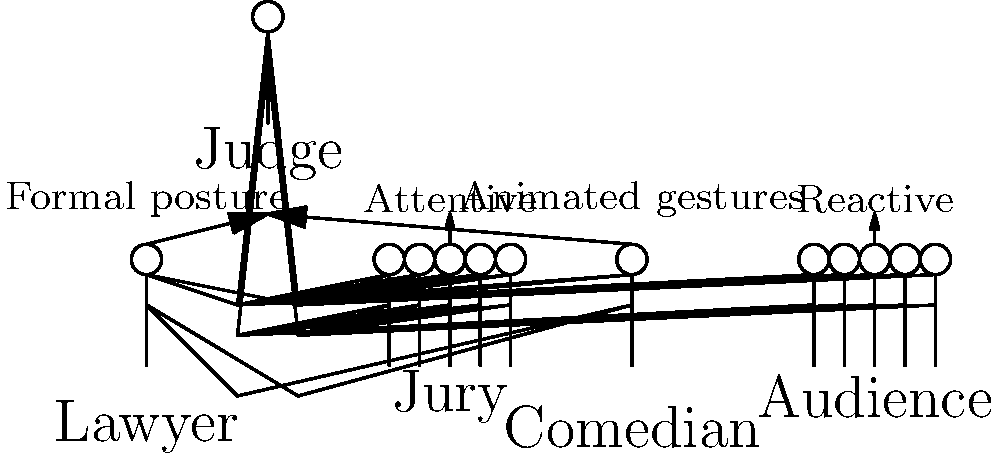Analyze the body language differences between the courtroom presentation and stand-up performance depicted in the stick figure diagrams. Which key aspect of body language is likely to be more exaggerated in the stand-up performance, and how does this contrast with the courtroom setting? To answer this question, let's break down the body language differences between the two settings:

1. Courtroom setting:
   a) The lawyer is shown with a straight posture, indicative of formal body language.
   b) The jury is seated and attentive, suggesting a more reserved atmosphere.
   c) The judge's presence adds to the formal nature of the setting.

2. Stand-up performance setting:
   a) The comedian is shown with a more dynamic posture, suggesting animated gestures.
   b) The audience is seated but labeled as "reactive," implying more engagement and expressiveness.

3. Key differences:
   a) Formality vs. Informality: The courtroom requires more controlled and formal body language, while stand-up allows for more expressive and informal gestures.
   b) Interaction level: Stand-up involves more direct interaction with the audience, whereas courtroom presentations are more structured.
   c) Emotional expression: Comedians often use exaggerated facial expressions and body movements to enhance their jokes, while lawyers must maintain a more composed demeanor.

4. Exaggerated aspect in stand-up:
   The most exaggerated aspect in stand-up performance is likely to be animated gestures. This is because:
   a) Comedians use physical comedy to enhance their verbal jokes.
   b) Expressive movements help to engage the audience and emphasize punchlines.
   c) Stand-up allows for more freedom in movement and expression compared to the restrictive courtroom environment.

5. Contrast with courtroom:
   In the courtroom, gestures are typically more restrained and controlled. Lawyers must maintain a professional demeanor and avoid distracting or overly dramatic movements that could be seen as inappropriate or manipulative in a legal setting.

Therefore, the key aspect of body language that is likely to be more exaggerated in the stand-up performance is animated gestures, which contrasts sharply with the controlled and formal body language required in the courtroom setting.
Answer: Animated gestures 